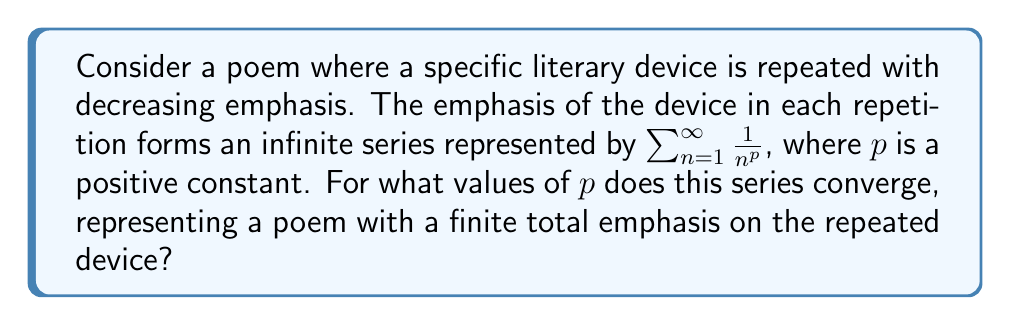Solve this math problem. To analyze the convergence of this series, we can use the p-series test:

1) The series $\sum_{n=1}^{\infty} \frac{1}{n^p}$ is called a p-series.

2) For a p-series:
   - If $p > 1$, the series converges.
   - If $p \leq 1$, the series diverges.

3) In this case, we want the series to converge, representing a finite total emphasis.

4) Therefore, we need $p > 1$ for convergence.

5) Intuitively, this means the emphasis on the literary device must decrease faster than $\frac{1}{n}$ for the total emphasis to be finite.

6) For example:
   - If $p = 2$, we get the convergent series $\sum_{n=1}^{\infty} \frac{1}{n^2}$, which equals $\frac{\pi^2}{6}$.
   - If $p = 1$, we get the divergent harmonic series $\sum_{n=1}^{\infty} \frac{1}{n}$.

7) In the context of poetry, $p > 1$ would represent a rapid decrease in emphasis, creating a more subtle repetition effect.
Answer: $p > 1$ 